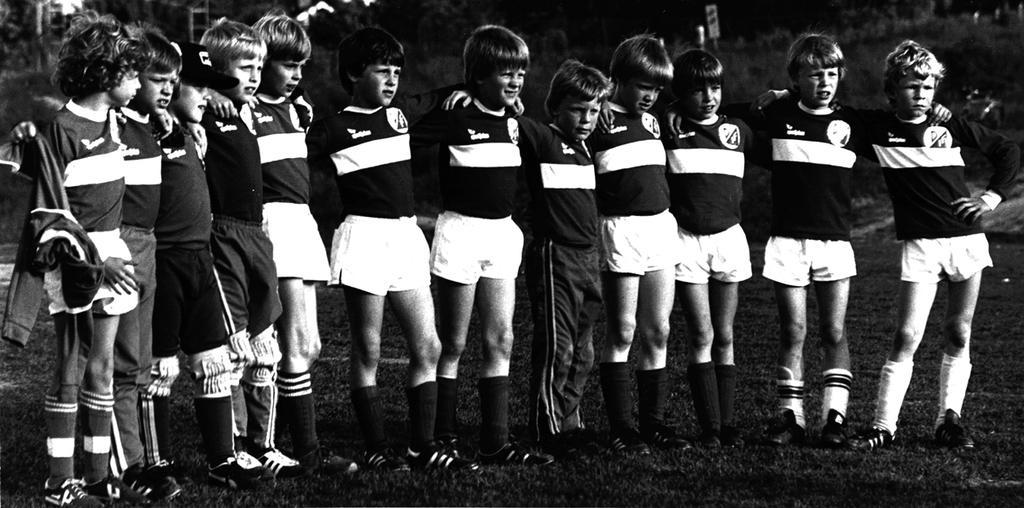Can you describe this image briefly? This picture describes about group of people, they are all standing on the grass, behind to them we can see few trees, and it is a black and white photography. 